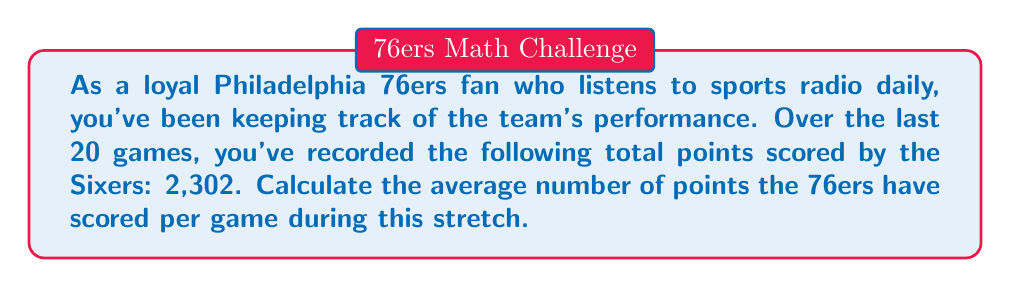What is the answer to this math problem? To calculate the average number of points scored per game, we need to use the formula for arithmetic mean:

$$ \text{Average} = \frac{\text{Sum of all values}}{\text{Number of values}} $$

In this case:
- Sum of all values = Total points scored = 2,302
- Number of values = Number of games = 20

Let's substitute these values into the formula:

$$ \text{Average points per game} = \frac{2,302}{20} $$

Now, let's perform the division:

$$ \text{Average points per game} = 115.1 $$

Therefore, the Philadelphia 76ers have scored an average of 115.1 points per game over the last 20 games.
Answer: $115.1$ points per game 